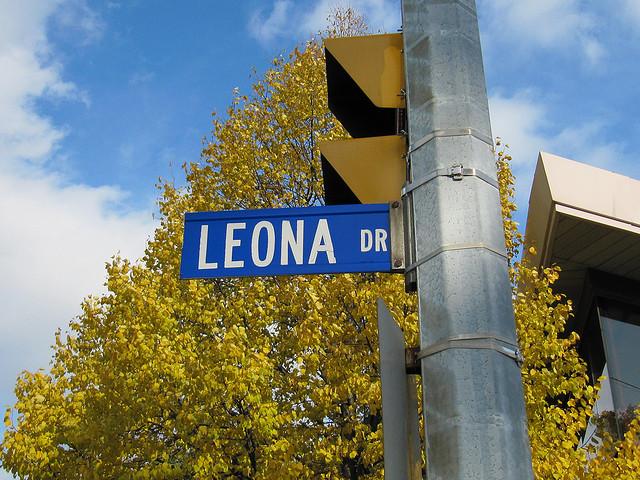What color is the tree?
Concise answer only. Yellow. How many sign are there?
Answer briefly. 1. What does the sign say?
Be succinct. Leona dr. What color are the sign letters?
Give a very brief answer. White. 